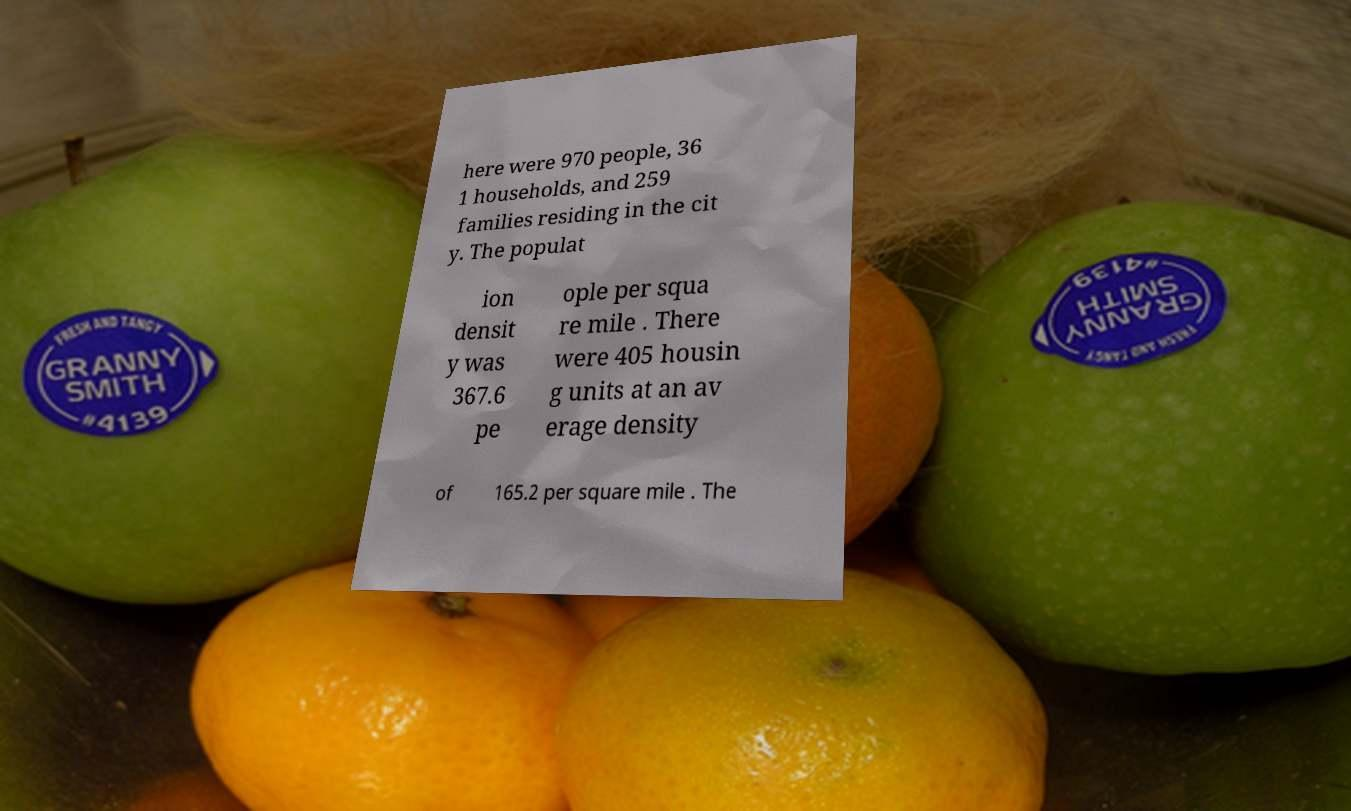What messages or text are displayed in this image? I need them in a readable, typed format. here were 970 people, 36 1 households, and 259 families residing in the cit y. The populat ion densit y was 367.6 pe ople per squa re mile . There were 405 housin g units at an av erage density of 165.2 per square mile . The 